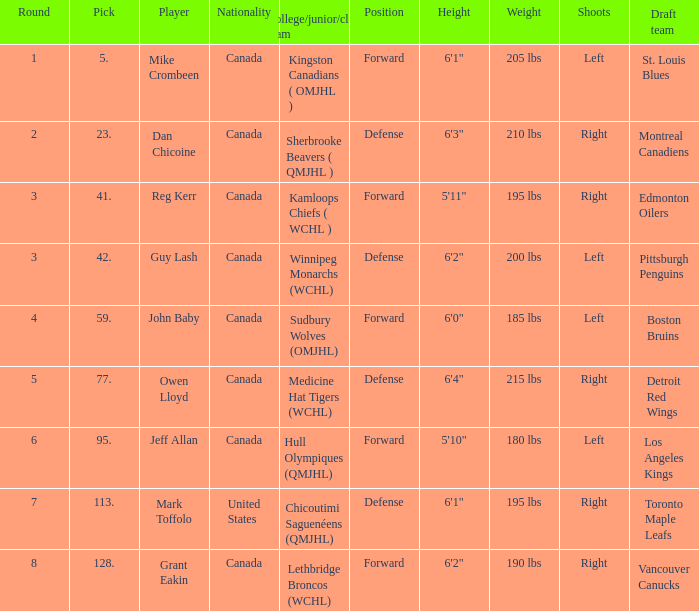Which College/junior/club team has a Round of 2? Sherbrooke Beavers ( QMJHL ). Help me parse the entirety of this table. {'header': ['Round', 'Pick', 'Player', 'Nationality', 'College/junior/club team', 'Position', 'Height', 'Weight', 'Shoots', 'Draft team '], 'rows': [['1', '5.', 'Mike Crombeen', 'Canada', 'Kingston Canadians ( OMJHL )', 'Forward', '6\'1"', '205 lbs', 'Left', 'St. Louis Blues'], ['2', '23.', 'Dan Chicoine', 'Canada', 'Sherbrooke Beavers ( QMJHL )', 'Defense', '6\'3"', '210 lbs', 'Right', 'Montreal Canadiens'], ['3', '41.', 'Reg Kerr', 'Canada', 'Kamloops Chiefs ( WCHL )', 'Forward', '5\'11"', '195 lbs', 'Right', 'Edmonton Oilers'], ['3', '42.', 'Guy Lash', 'Canada', 'Winnipeg Monarchs (WCHL)', 'Defense', '6\'2"', '200 lbs', 'Left', 'Pittsburgh Penguins'], ['4', '59.', 'John Baby', 'Canada', 'Sudbury Wolves (OMJHL)', 'Forward', '6\'0"', '185 lbs', 'Left', 'Boston Bruins'], ['5', '77.', 'Owen Lloyd', 'Canada', 'Medicine Hat Tigers (WCHL)', 'Defense', '6\'4"', '215 lbs', 'Right', 'Detroit Red Wings'], ['6', '95.', 'Jeff Allan', 'Canada', 'Hull Olympiques (QMJHL)', 'Forward', '5\'10"', '180 lbs', 'Left', 'Los Angeles Kings'], ['7', '113.', 'Mark Toffolo', 'United States', 'Chicoutimi Saguenéens (QMJHL)', 'Defense', '6\'1"', '195 lbs', 'Right', 'Toronto Maple Leafs'], ['8', '128.', 'Grant Eakin', 'Canada', 'Lethbridge Broncos (WCHL)', 'Forward', '6\'2"', '190 lbs', 'Right', 'Vancouver Canucks']]} 